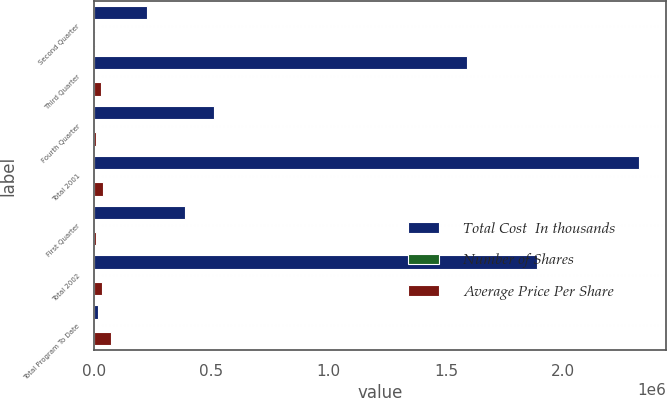Convert chart. <chart><loc_0><loc_0><loc_500><loc_500><stacked_bar_chart><ecel><fcel>Second Quarter<fcel>Third Quarter<fcel>Fourth Quarter<fcel>Total 2001<fcel>First Quarter<fcel>Total 2002<fcel>Total Program To Date<nl><fcel>Total Cost  In thousands<fcel>222900<fcel>1.5898e+06<fcel>510500<fcel>2.3232e+06<fcel>385100<fcel>1.8877e+06<fcel>17431.5<nl><fcel>Number of Shares<fcel>15.55<fcel>16.75<fcel>16.12<fcel>16.5<fcel>17.54<fcel>17.47<fcel>16.94<nl><fcel>Average Price Per Share<fcel>3465<fcel>26634<fcel>8229<fcel>38328<fcel>6754<fcel>32987<fcel>71315<nl></chart> 